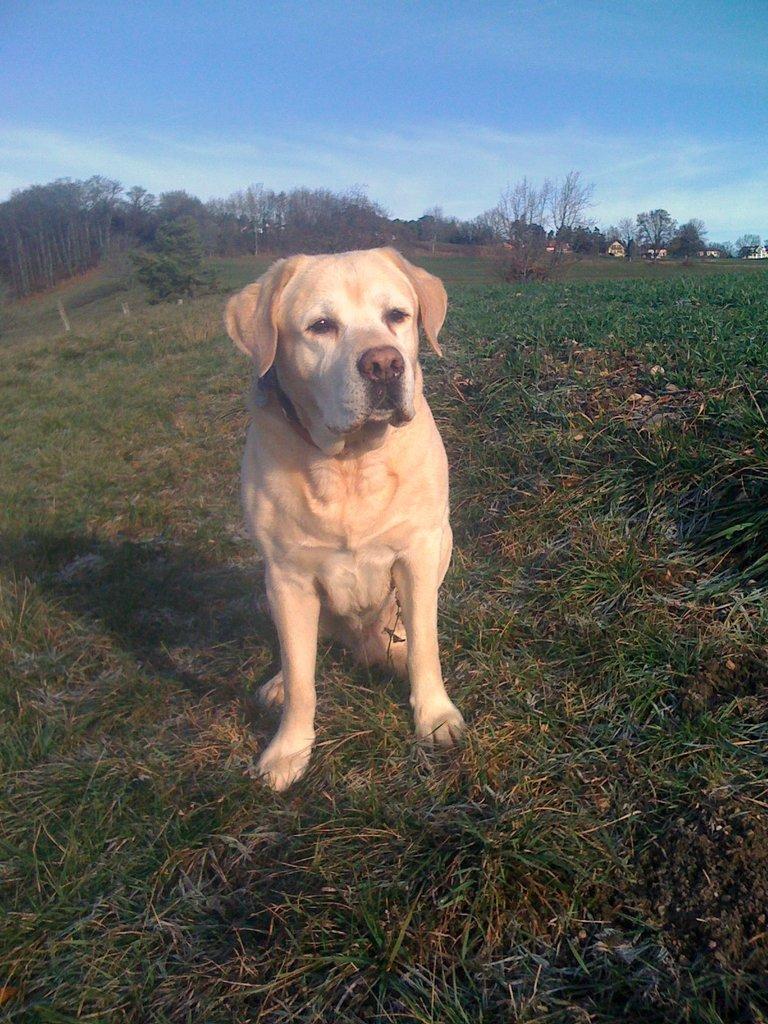Please provide a concise description of this image. In the image we can see there is a dog sitting on the ground and the ground is covered with grass. Behind there are trees and the sky is clear. 